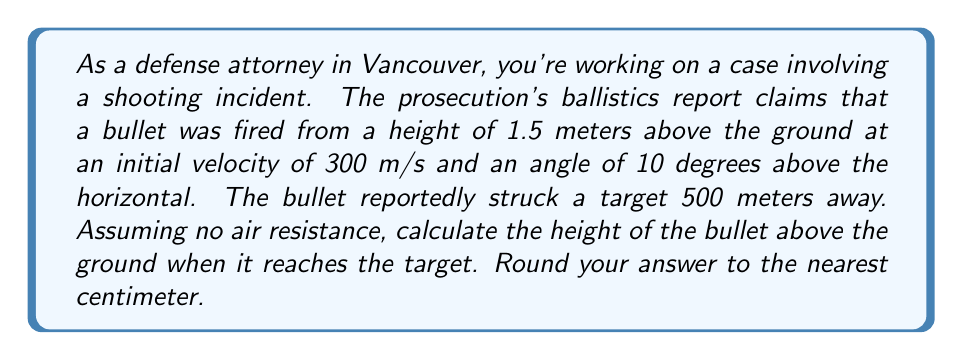Show me your answer to this math problem. To solve this problem, we'll use the equations of projectile motion. Let's break it down step by step:

1) First, we need to understand the components of the velocity:
   Initial velocity in x-direction: $v_{0x} = v_0 \cos \theta$
   Initial velocity in y-direction: $v_{0y} = v_0 \sin \theta$

   Where $v_0 = 300$ m/s and $\theta = 10°$

2) Calculate these components:
   $v_{0x} = 300 \cos 10° \approx 295.44$ m/s
   $v_{0y} = 300 \sin 10° \approx 52.14$ m/s

3) The time taken for the bullet to reach the target can be calculated using the horizontal distance:
   $x = v_{0x}t$
   $500 = 295.44t$
   $t = \frac{500}{295.44} \approx 1.69$ seconds

4) Now we can use the equation for vertical displacement:
   $y = y_0 + v_{0y}t - \frac{1}{2}gt^2$

   Where:
   $y_0 = 1.5$ m (initial height)
   $g = 9.8$ m/s² (acceleration due to gravity)

5) Plug in the values:
   $y = 1.5 + (52.14 \times 1.69) - \frac{1}{2} \times 9.8 \times 1.69^2$
   $y = 1.5 + 88.12 - 14.01$
   $y = 75.61$ m

6) Round to the nearest centimeter:
   $y \approx 75.61$ m = 7561 cm

Therefore, the height of the bullet when it reaches the target is approximately 7561 cm above the ground.
Answer: 7561 cm 